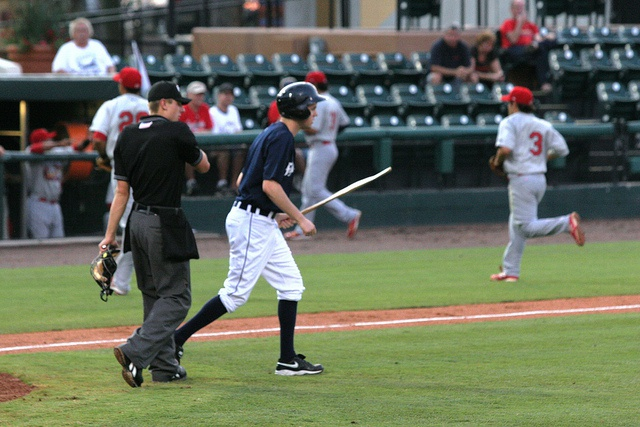Describe the objects in this image and their specific colors. I can see people in gray, black, brown, and purple tones, people in gray, black, and lavender tones, chair in gray, black, blue, and darkgray tones, people in gray, darkgray, and lavender tones, and people in gray and darkgray tones in this image. 